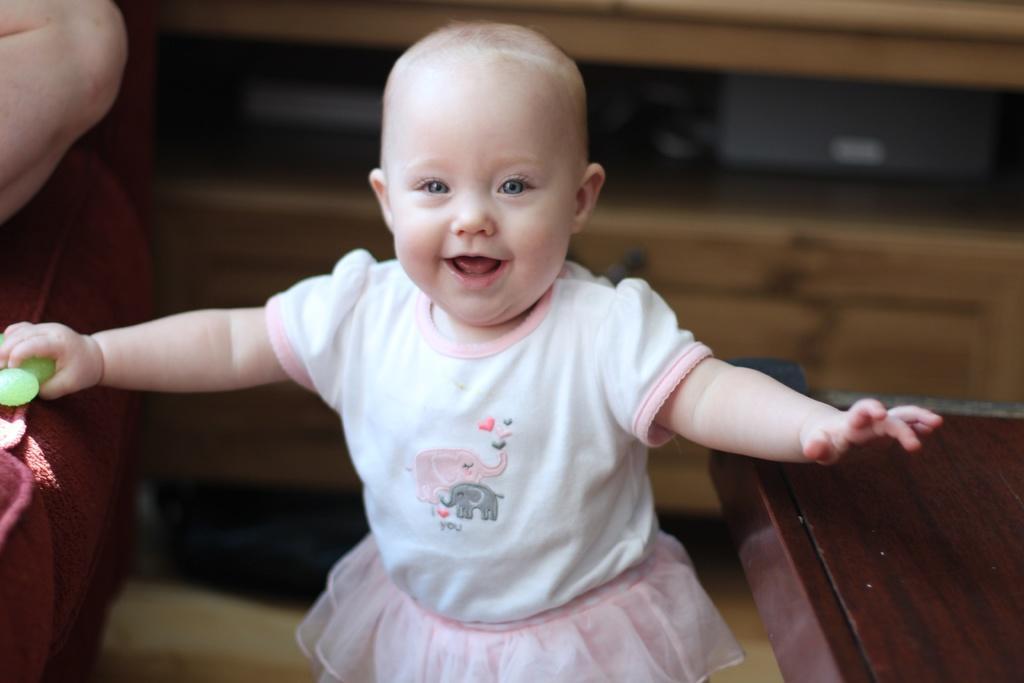Could you give a brief overview of what you see in this image? In the center of the image, we can see a baby holding and object and in the background, we can see a person's hand and there is a couch and we can a table and there is a cupboard. 